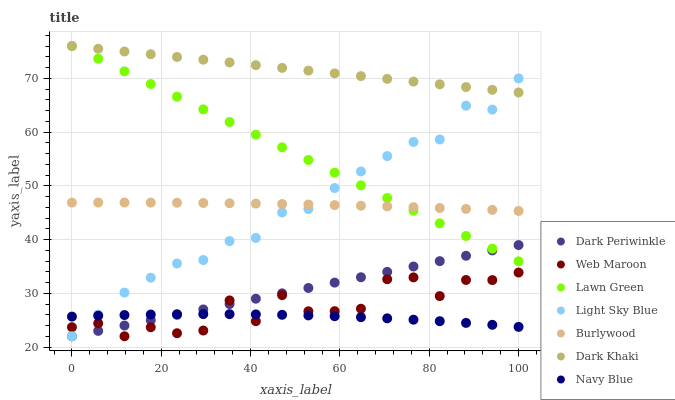Does Navy Blue have the minimum area under the curve?
Answer yes or no. Yes. Does Dark Khaki have the maximum area under the curve?
Answer yes or no. Yes. Does Burlywood have the minimum area under the curve?
Answer yes or no. No. Does Burlywood have the maximum area under the curve?
Answer yes or no. No. Is Dark Khaki the smoothest?
Answer yes or no. Yes. Is Web Maroon the roughest?
Answer yes or no. Yes. Is Burlywood the smoothest?
Answer yes or no. No. Is Burlywood the roughest?
Answer yes or no. No. Does Web Maroon have the lowest value?
Answer yes or no. Yes. Does Burlywood have the lowest value?
Answer yes or no. No. Does Dark Khaki have the highest value?
Answer yes or no. Yes. Does Burlywood have the highest value?
Answer yes or no. No. Is Web Maroon less than Lawn Green?
Answer yes or no. Yes. Is Lawn Green greater than Web Maroon?
Answer yes or no. Yes. Does Dark Periwinkle intersect Light Sky Blue?
Answer yes or no. Yes. Is Dark Periwinkle less than Light Sky Blue?
Answer yes or no. No. Is Dark Periwinkle greater than Light Sky Blue?
Answer yes or no. No. Does Web Maroon intersect Lawn Green?
Answer yes or no. No. 